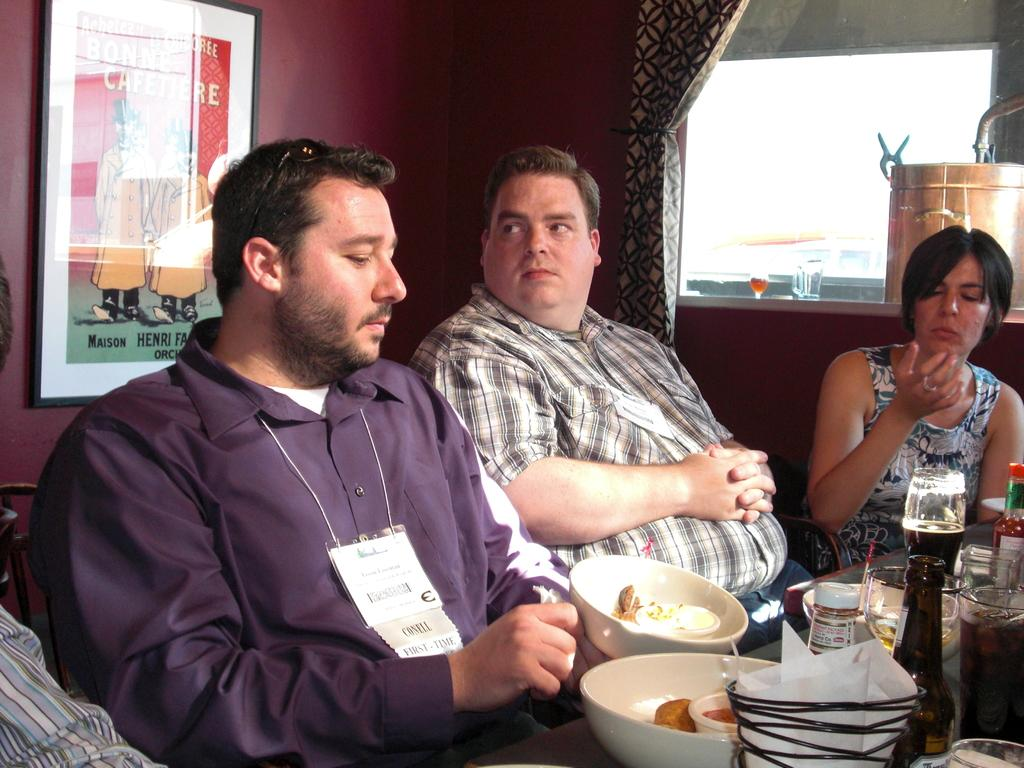How many people are seated in the image? There are three people seated in the image. What are the people sitting on? The people are seated on chairs. What can be seen on the table in the image? There are bowls, food, bottles, and sauces on the table. Is there any decoration or personal item on the wall? Yes, there is a photo frame on the wall. Are the boys playing a game in the image? There is no mention of boys or a game in the image; it features three people seated on chairs. What type of knife is being used by one of the people in the image? There is no knife present in the image. 